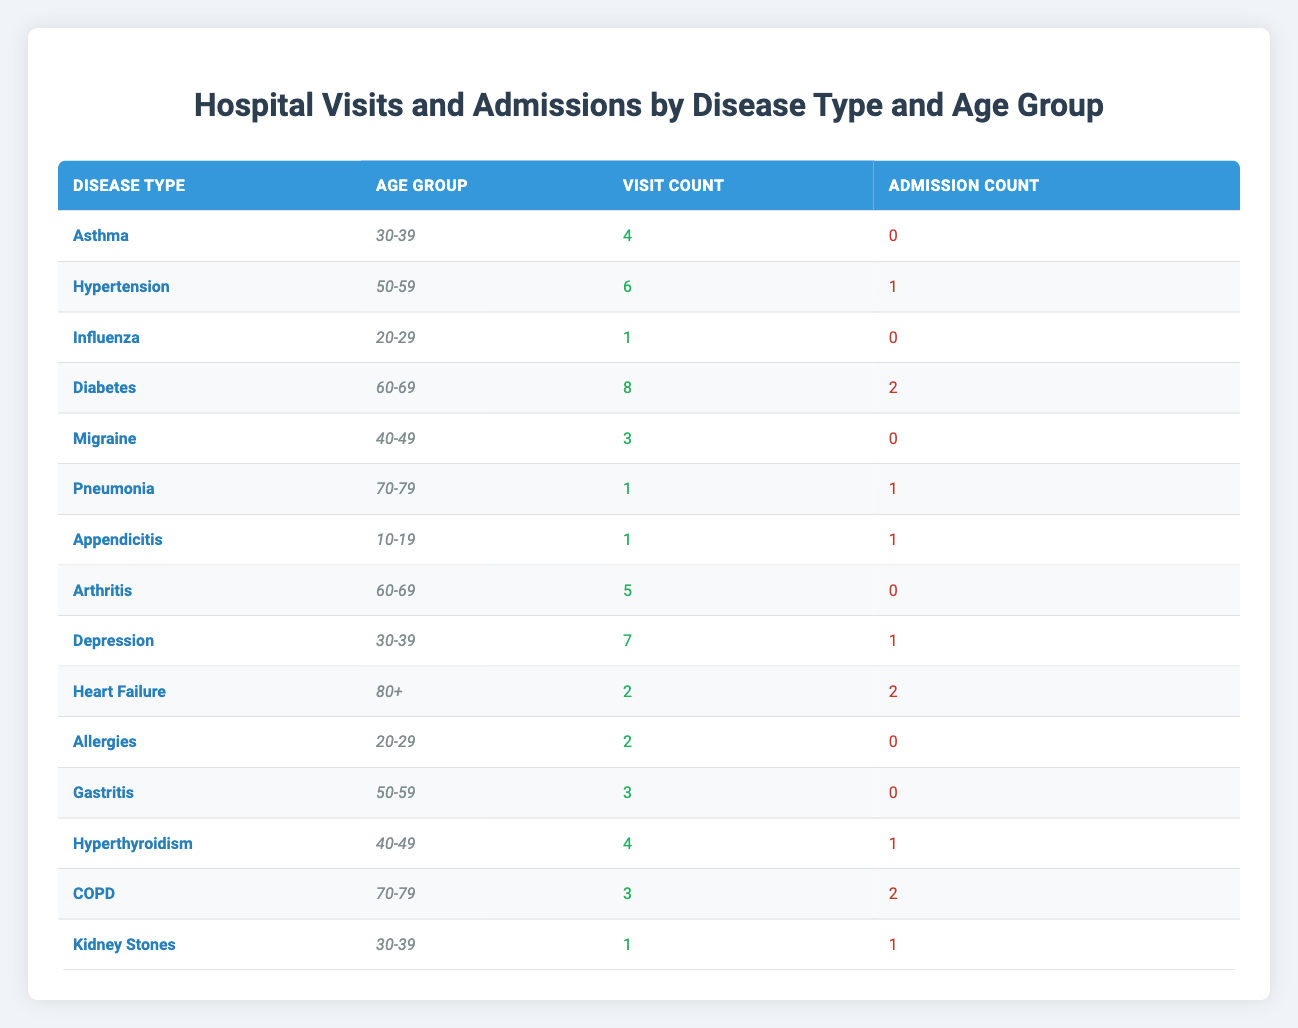What is the total visit count for patients with Diabetes in the age group 60-69? There is one row corresponding to Diabetes in the age group 60-69, which shows a visit count of 8. Therefore, the total visit count for this disease type in this age group is simply 8.
Answer: 8 How many patients in the age group 30-39 had admissions? We need to look for all rows where the age group is 30-39. The disease types are Asthma (0 admissions), Depression (1 admission), and Kidney Stones (1 admission). Adding these up gives us a total of 1 + 1 = 2 admissions in this age group.
Answer: 2 What is the average visit count for patients with diseases that resulted in hospital admissions? We first identify the diseases with admissions: Hypertension (6 visits), Diabetes (8 visits), Pneumonia (1 visit), Appendicitis (1 visit), Heart Failure (2 visits), COPD (3 visits). Summing these gives us 6 + 8 + 1 + 1 + 2 + 3 = 21 total visits. There are 6 diseases, so the average visit count is 21 / 6 = 3.5.
Answer: 3.5 Is there any disease in the age group 70-79 that had more visits than admissions? In the age group 70-79, we have two diseases: Pneumonia (1 visit, 1 admission) and COPD (3 visits, 2 admissions). Comparing visits to admissions, COPD had more visits (3) than admissions (2). Thus, the answer is yes.
Answer: Yes Which disease type in the age group 60-69 has the highest visit count? In the age group 60-69, there are two disease types listed: Diabetes with 8 visits and Arthritis with 5 visits. Comparing the two, Diabetes has the highest visit count at 8.
Answer: Diabetes How many total admissions were there for the 40-49 age group? For the age group 40-49, we have two diseases: Migraine (0 admissions) and Hyperthyroidism (1 admission). Adding these admissions gives us a total of 0 + 1 = 1 admission.
Answer: 1 What is the difference in visit counts between the age groups 20-29 and 70-79? For the age group 20-29, we have Influenza (1 visit) and Allergies (2 visits), totaling 1 + 2 = 3 visits. In the 70-79 age group, we have Pneumonia (1 visit) and COPD (3 visits), totaling 1 + 3 = 4 visits. The difference is 4 - 3 = 1.
Answer: 1 Do any patients in the age group 10-19 have a higher admission count than visit count? In the age group 10-19, Appendicitis is listed with 1 admission and 1 visit. Since the admission count is not higher than the visit count, the answer is no.
Answer: No What is the total visit count for all patients with Outpatient visit types? Summing the visit counts from all Outpatient visit types: Asthma (4), Hypertension (6), Diabetes (8), Migraine (3), Arthritis (5), Depression (7), Gastritis (3), Hyperthyroidism (4) gives us a total of 4 + 6 + 8 + 3 + 5 + 7 + 3 + 4 = 40 visits.
Answer: 40 